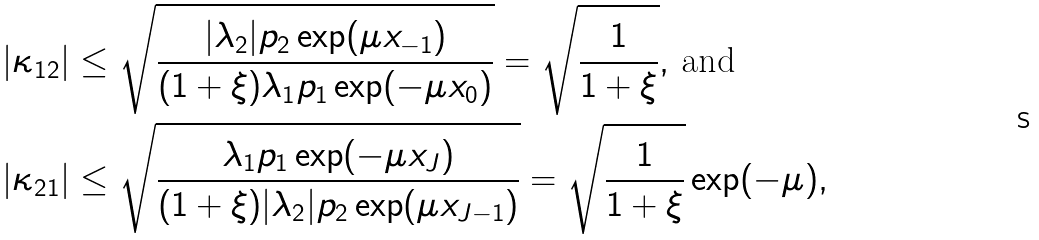<formula> <loc_0><loc_0><loc_500><loc_500>| \kappa _ { 1 2 } | & \leq \sqrt { \frac { | { \lambda _ { 2 } } | { p _ { 2 } } \exp ( \mu x _ { - 1 } ) } { ( 1 + \xi ) { \lambda _ { 1 } } { p _ { 1 } } \exp ( - \mu x _ { 0 } ) } } = \sqrt { \frac { 1 } { 1 + \xi } } , \, \text {and} \\ | \kappa _ { 2 1 } | & \leq \sqrt { \frac { { \lambda _ { 1 } } { p _ { 1 } } \exp ( - \mu x _ { J } ) } { ( 1 + \xi ) | { \lambda _ { 2 } } | { p _ { 2 } } \exp ( \mu x _ { J - 1 } ) } } = \sqrt { \frac { 1 } { 1 + \xi } } \exp ( - \mu ) ,</formula> 